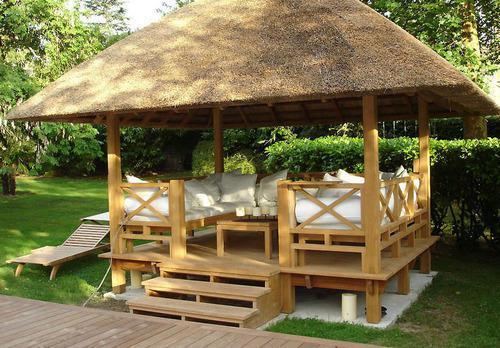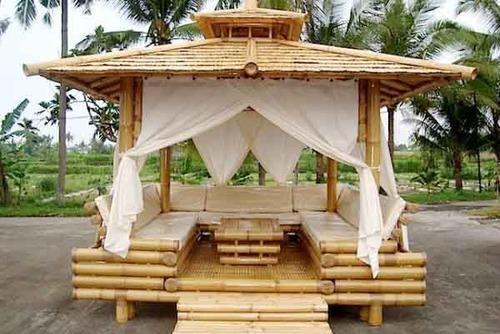The first image is the image on the left, the second image is the image on the right. For the images shown, is this caption "The combined images include a two-story structure with wood rails on it and multiple tiered round thatched roofs." true? Answer yes or no. No. 